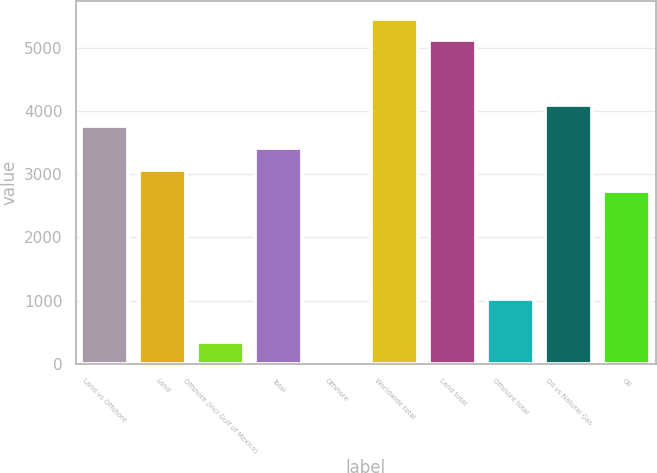Convert chart. <chart><loc_0><loc_0><loc_500><loc_500><bar_chart><fcel>Land vs Offshore<fcel>Land<fcel>Offshore (incl Gulf of Mexico)<fcel>Total<fcel>Offshore<fcel>Worldwide total<fcel>Land total<fcel>Offshore total<fcel>Oil vs Natural Gas<fcel>Oil<nl><fcel>3751.9<fcel>3070.1<fcel>342.9<fcel>3411<fcel>2<fcel>5456.4<fcel>5115.5<fcel>1024.7<fcel>4092.8<fcel>2729.2<nl></chart> 